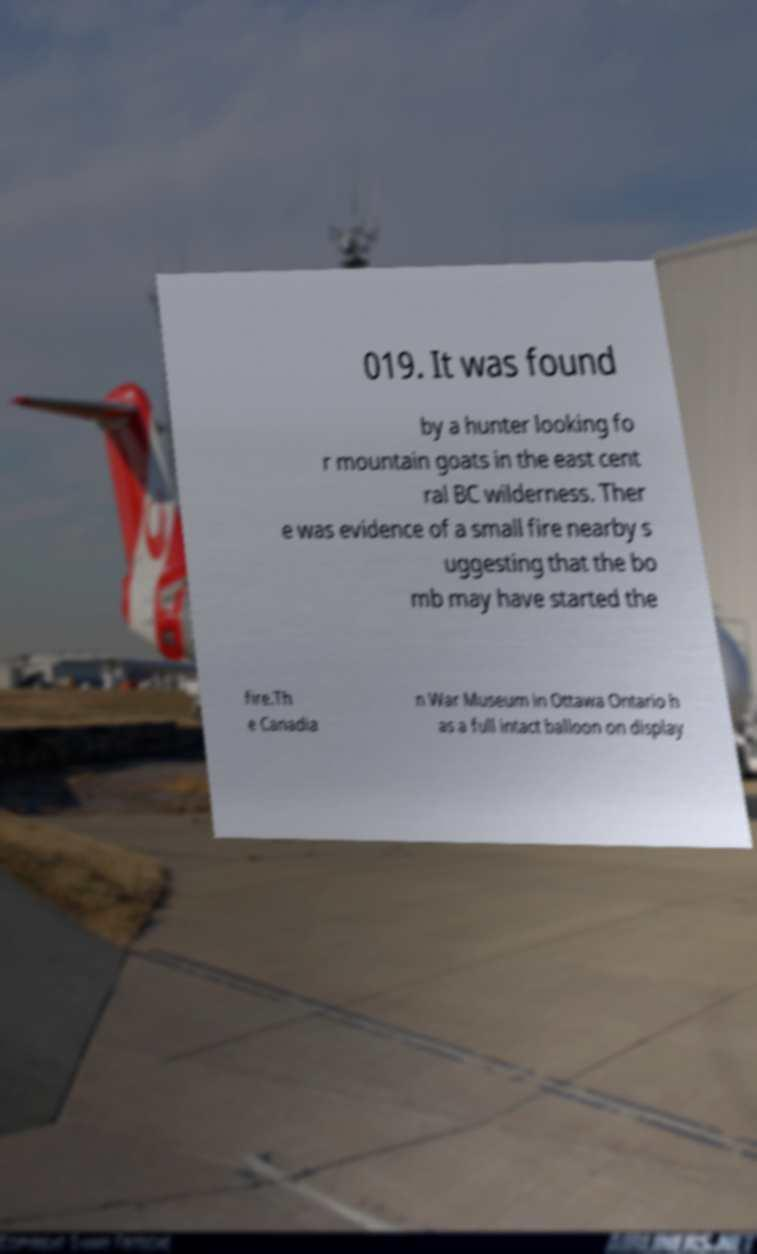Can you accurately transcribe the text from the provided image for me? 019. It was found by a hunter looking fo r mountain goats in the east cent ral BC wilderness. Ther e was evidence of a small fire nearby s uggesting that the bo mb may have started the fire.Th e Canadia n War Museum in Ottawa Ontario h as a full intact balloon on display 